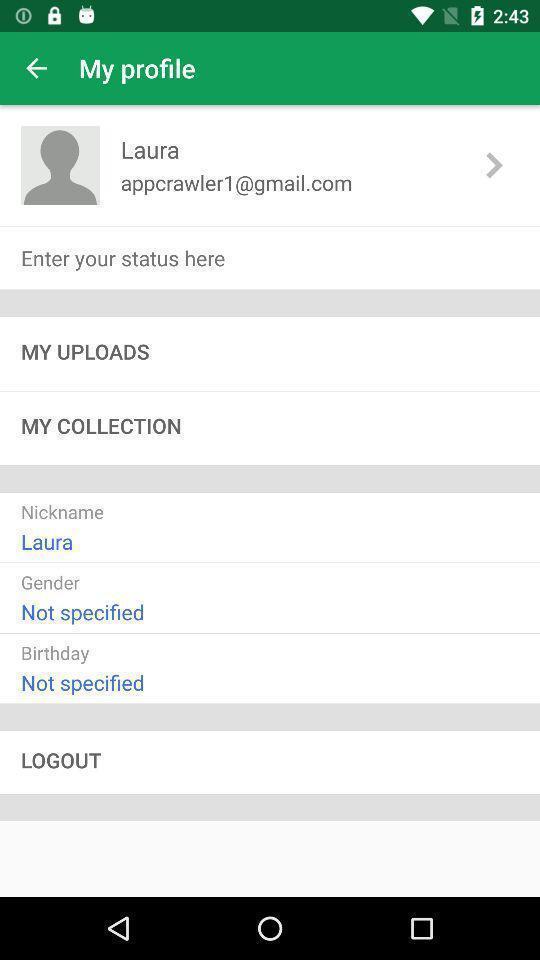Describe this image in words. Profile page in a social app. 